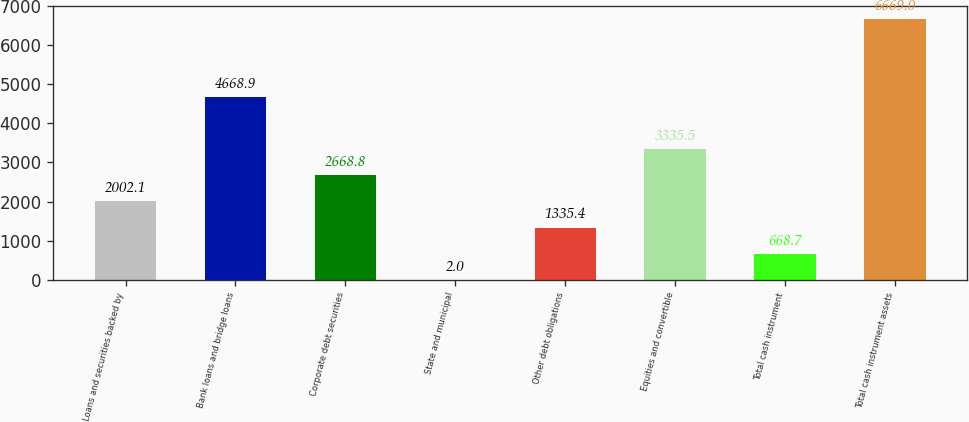<chart> <loc_0><loc_0><loc_500><loc_500><bar_chart><fcel>Loans and securities backed by<fcel>Bank loans and bridge loans<fcel>Corporate debt securities<fcel>State and municipal<fcel>Other debt obligations<fcel>Equities and convertible<fcel>Total cash instrument<fcel>Total cash instrument assets<nl><fcel>2002.1<fcel>4668.9<fcel>2668.8<fcel>2<fcel>1335.4<fcel>3335.5<fcel>668.7<fcel>6669<nl></chart> 